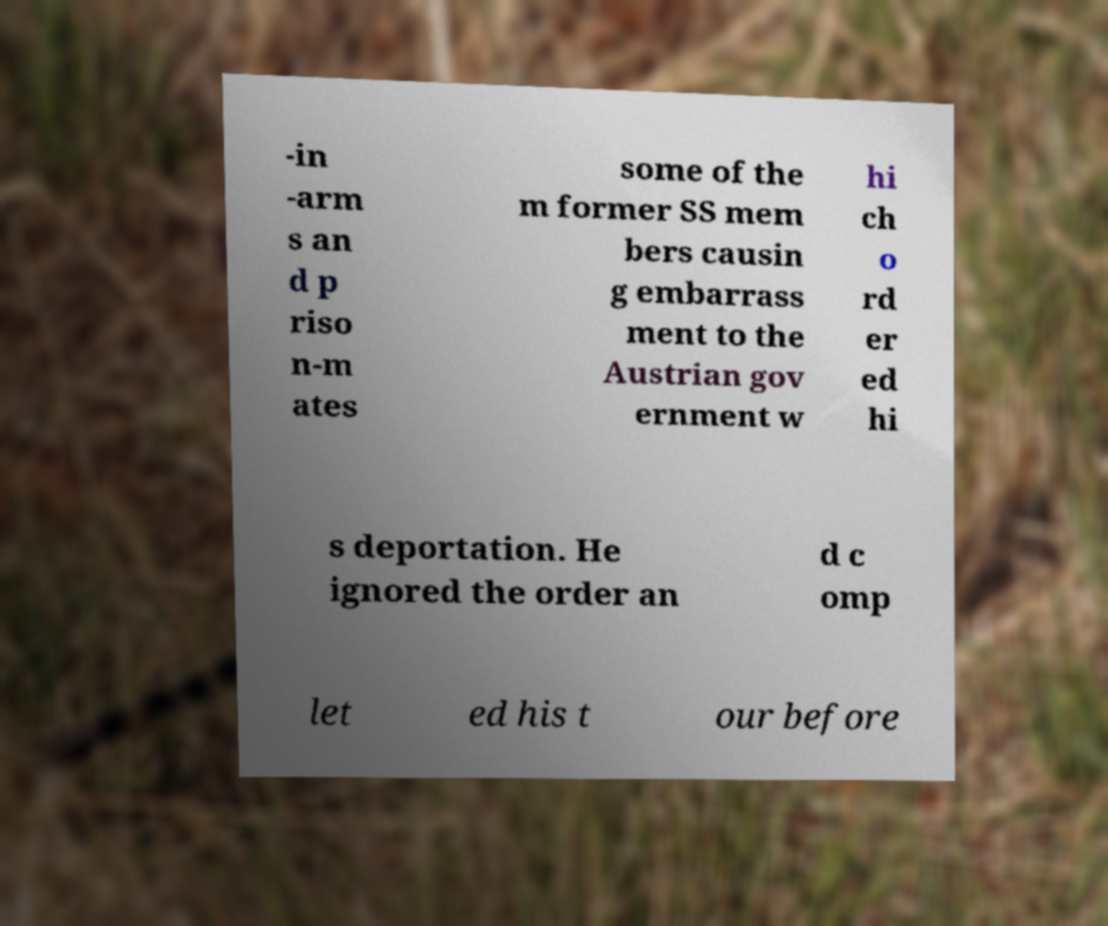There's text embedded in this image that I need extracted. Can you transcribe it verbatim? -in -arm s an d p riso n-m ates some of the m former SS mem bers causin g embarrass ment to the Austrian gov ernment w hi ch o rd er ed hi s deportation. He ignored the order an d c omp let ed his t our before 